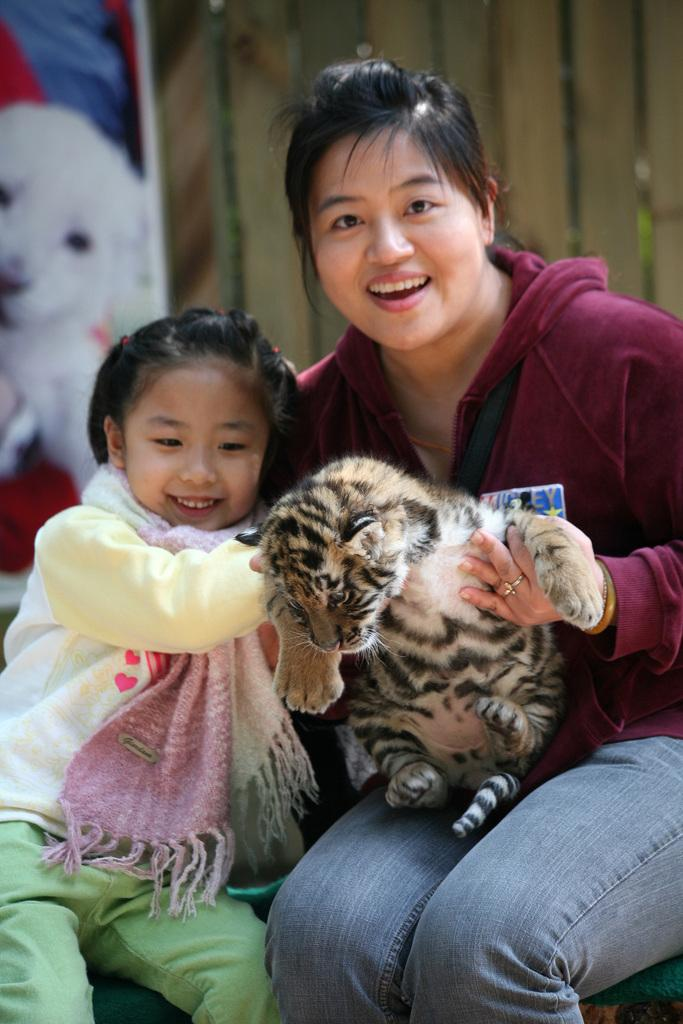Who is present in the image? There is a woman and a girl in the image. What are the woman and the girl doing? They are laughing in the image. What are they holding in their hands? They are holding an animal in their hands. What can be seen in the background of the image? There is a hoarding in the background of the image. What type of gold jewelry is the woman wearing in the image? There is no gold jewelry visible on the woman in the image. What event is taking place in the image? The image does not depict a specific event; it simply shows a woman and a girl laughing while holding an animal. 